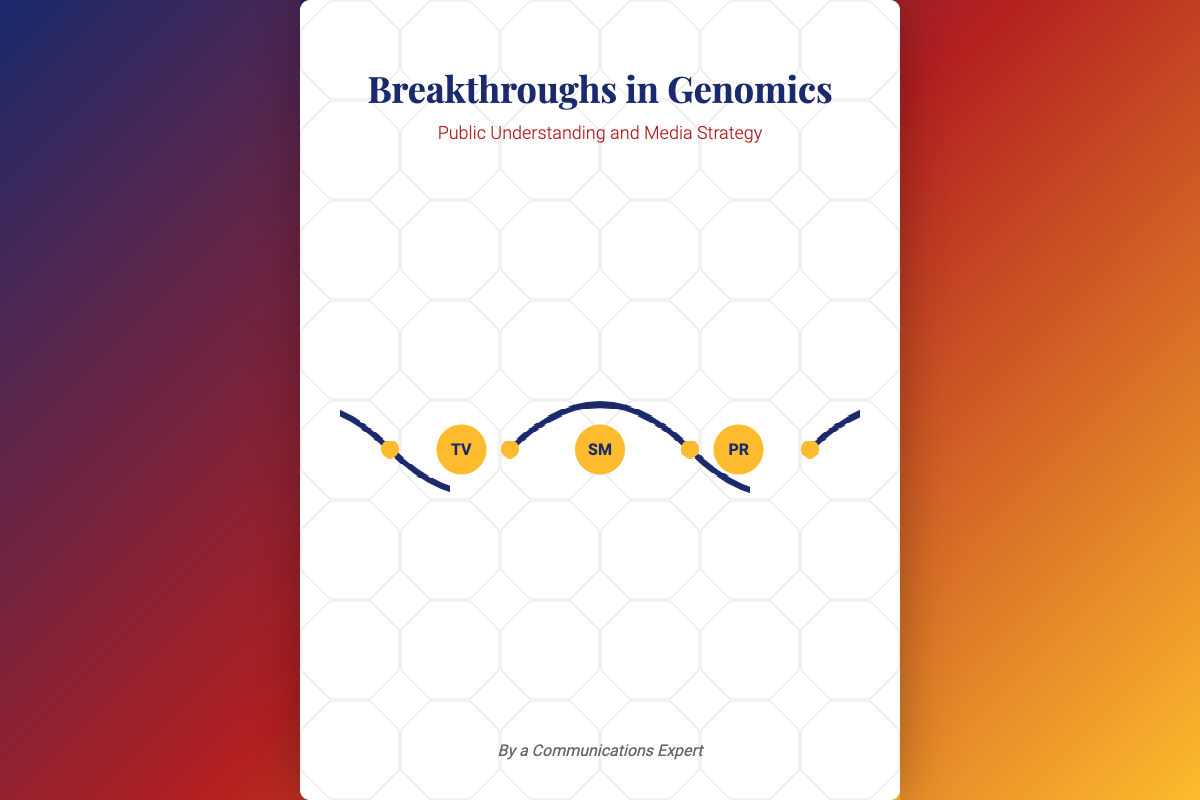What is the title of the book? The title is prominently displayed in large font on the cover.
Answer: Breakthroughs in Genomics What is the subtitle of the book? The subtitle is found directly underneath the main title, indicating the book's focus.
Answer: Public Understanding and Media Strategy How many media icons are present on the cover? The number of icons is counted based on their visibility in the design.
Answer: 3 Which color is primarily used for the author's name? The author's name color is evident in the bottom section of the cover.
Answer: Gray What imagery is used as a background? The background features a pattern that complements the book's theme.
Answer: DNA strands What is symbolized by the 'TV' icon? The 'TV' icon indicates a specific type of media representation related to the book's topic.
Answer: Television What is the main purpose of the book based on its title? The title suggests a focus on a particular area of communication related to genomics.
Answer: Promoting understanding Who is the author of the book? The name of the author is mentioned at the bottom of the cover.
Answer: A Communications Expert What visual theme is incorporated in the book cover? The visual theme is derived from elements relevant to the content of the book.
Answer: Media channels 